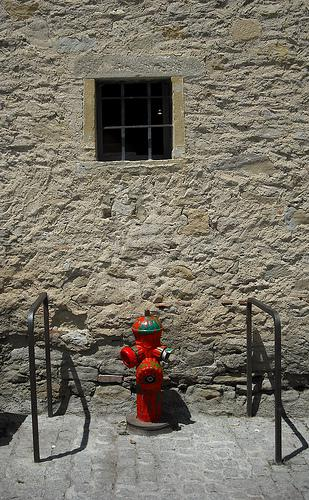Question: what is the ground made of?
Choices:
A. Dirt.
B. Grass.
C. Mud.
D. Stone.
Answer with the letter. Answer: D Question: where is the window?
Choices:
A. Above the hydrant.
B. In the wall.
C. Above the door.
D. Over the railing.
Answer with the letter. Answer: A Question: who is standing near the hydrant?
Choices:
A. The man.
B. No one.
C. The boy.
D. The woman.
Answer with the letter. Answer: B 